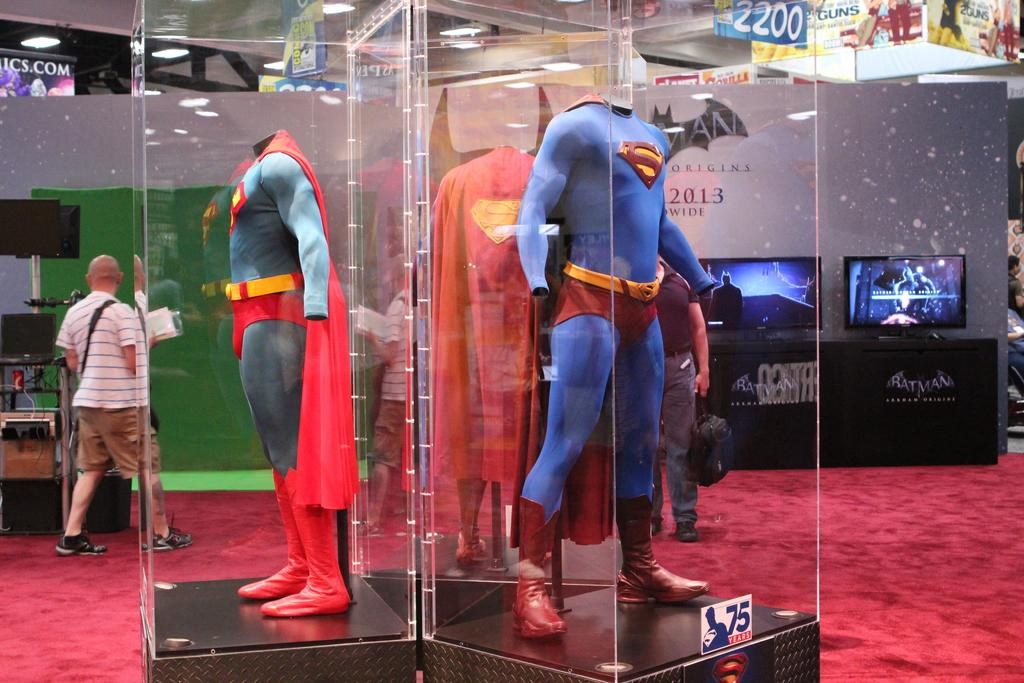<image>
Give a short and clear explanation of the subsequent image. A Superman costume sits behind the glass and the year 2013 is shown in the back 